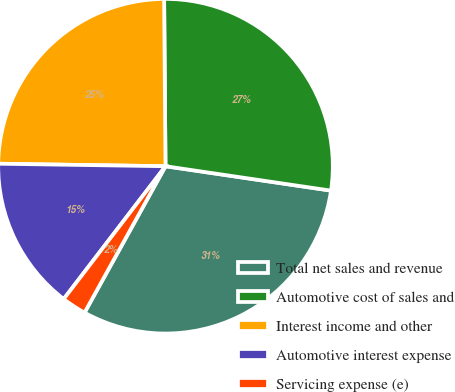<chart> <loc_0><loc_0><loc_500><loc_500><pie_chart><fcel>Total net sales and revenue<fcel>Automotive cost of sales and<fcel>Interest income and other<fcel>Automotive interest expense<fcel>Servicing expense (e)<nl><fcel>30.71%<fcel>27.46%<fcel>24.63%<fcel>14.83%<fcel>2.37%<nl></chart> 